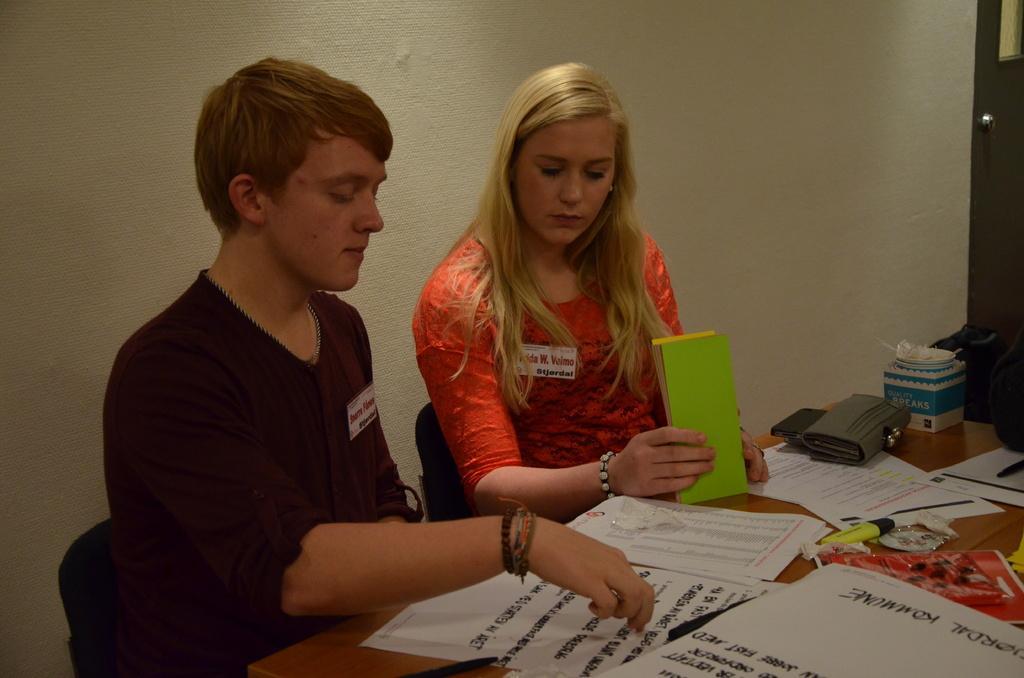Can you describe this image briefly? In the image there is a man in black shirt and a woman in orange top and blond hair sitting in front of table with papers,book,pen,purse on it and behind them there is wall, on the right side there is a door. 